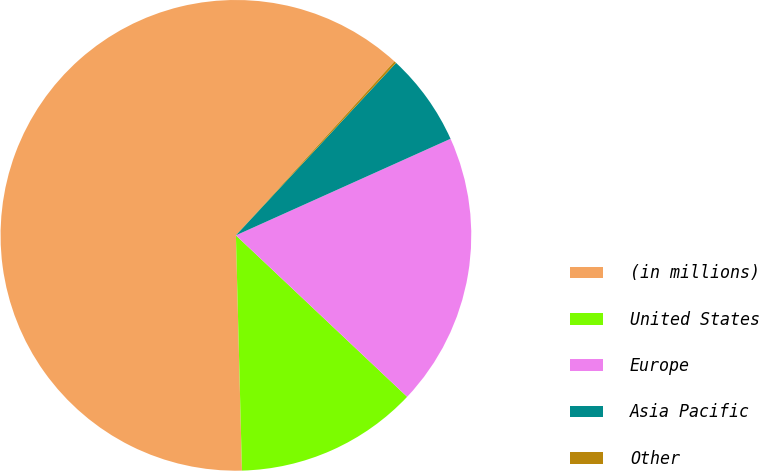<chart> <loc_0><loc_0><loc_500><loc_500><pie_chart><fcel>(in millions)<fcel>United States<fcel>Europe<fcel>Asia Pacific<fcel>Other<nl><fcel>62.17%<fcel>12.56%<fcel>18.76%<fcel>6.36%<fcel>0.15%<nl></chart> 